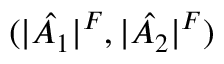Convert formula to latex. <formula><loc_0><loc_0><loc_500><loc_500>( | \hat { A _ { 1 } } | ^ { F } , | \hat { A _ { 2 } } | ^ { F } )</formula> 